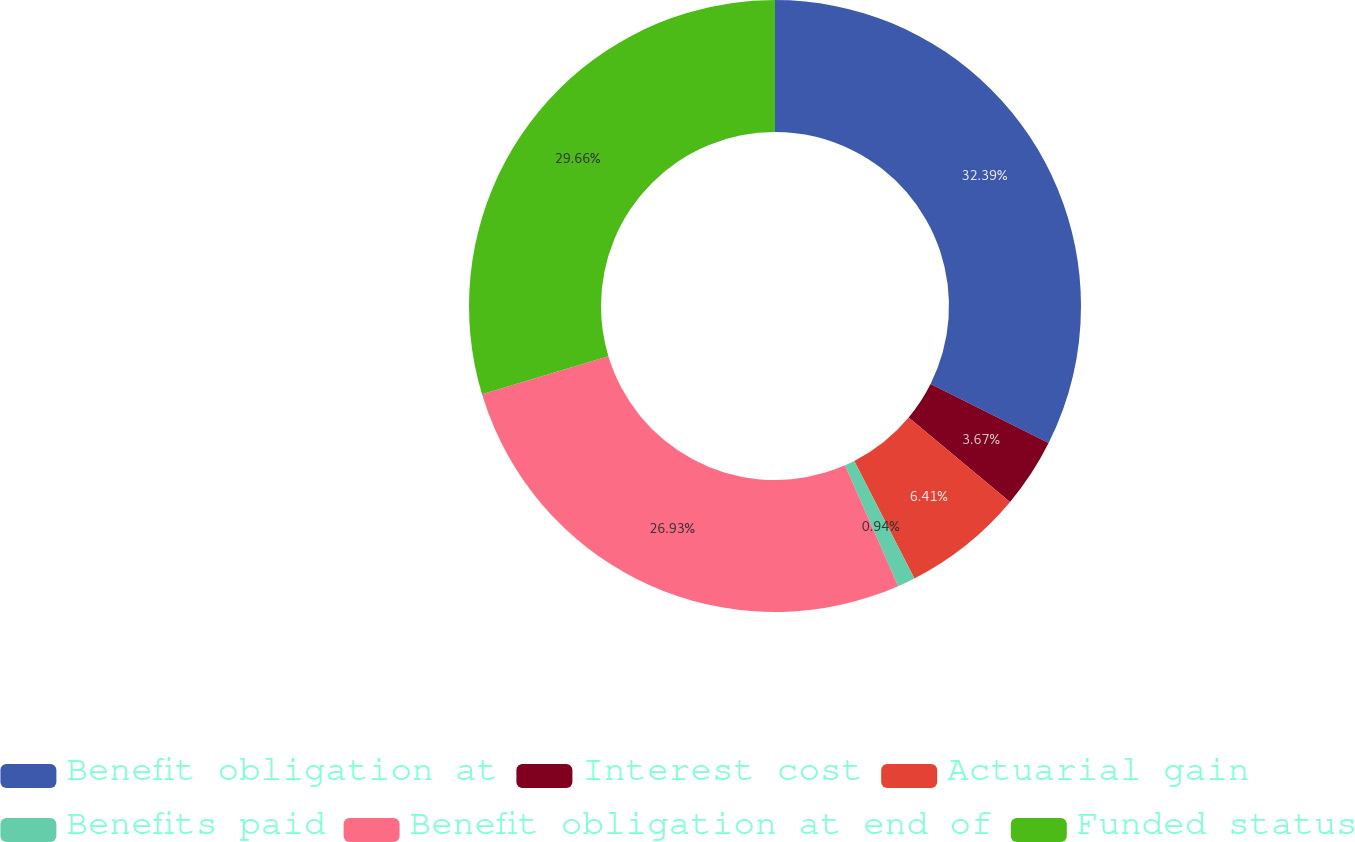Convert chart to OTSL. <chart><loc_0><loc_0><loc_500><loc_500><pie_chart><fcel>Benefit obligation at<fcel>Interest cost<fcel>Actuarial gain<fcel>Benefits paid<fcel>Benefit obligation at end of<fcel>Funded status<nl><fcel>32.39%<fcel>3.67%<fcel>6.41%<fcel>0.94%<fcel>26.93%<fcel>29.66%<nl></chart> 